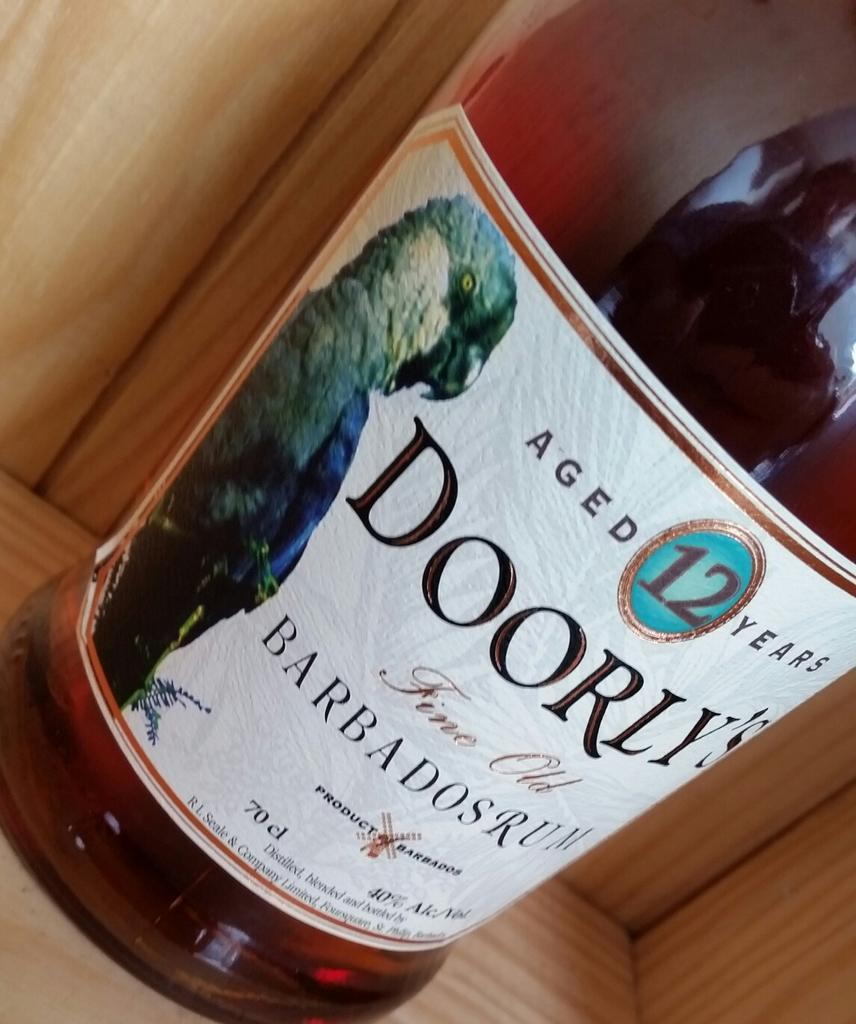Can you describe this image briefly? Here we can see a bottle on wooden surface. On this bottle there is a sticker. Something written on this sticker and we can see a picture of a bird.   